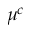<formula> <loc_0><loc_0><loc_500><loc_500>\mu ^ { c }</formula> 